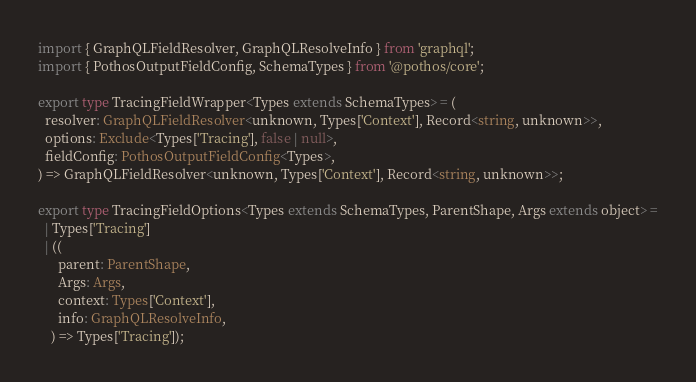Convert code to text. <code><loc_0><loc_0><loc_500><loc_500><_TypeScript_>import { GraphQLFieldResolver, GraphQLResolveInfo } from 'graphql';
import { PothosOutputFieldConfig, SchemaTypes } from '@pothos/core';

export type TracingFieldWrapper<Types extends SchemaTypes> = (
  resolver: GraphQLFieldResolver<unknown, Types['Context'], Record<string, unknown>>,
  options: Exclude<Types['Tracing'], false | null>,
  fieldConfig: PothosOutputFieldConfig<Types>,
) => GraphQLFieldResolver<unknown, Types['Context'], Record<string, unknown>>;

export type TracingFieldOptions<Types extends SchemaTypes, ParentShape, Args extends object> =
  | Types['Tracing']
  | ((
      parent: ParentShape,
      Args: Args,
      context: Types['Context'],
      info: GraphQLResolveInfo,
    ) => Types['Tracing']);
</code> 